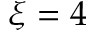<formula> <loc_0><loc_0><loc_500><loc_500>\xi = 4</formula> 